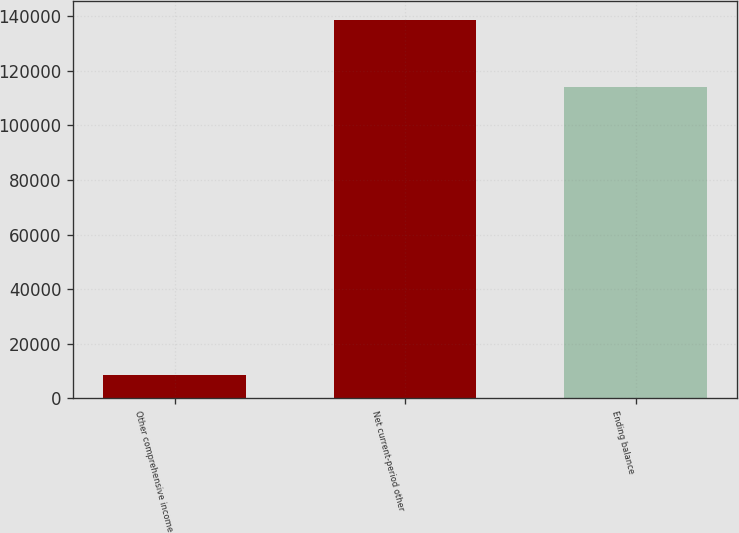<chart> <loc_0><loc_0><loc_500><loc_500><bar_chart><fcel>Other comprehensive income<fcel>Net current-period other<fcel>Ending balance<nl><fcel>8567<fcel>138560<fcel>114126<nl></chart> 